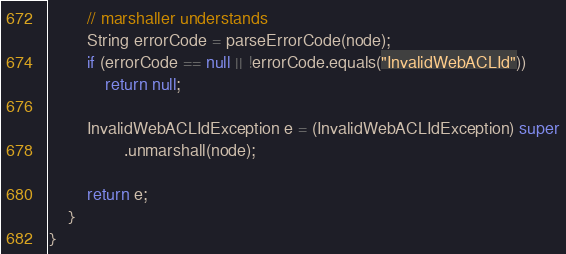<code> <loc_0><loc_0><loc_500><loc_500><_Java_>        // marshaller understands
        String errorCode = parseErrorCode(node);
        if (errorCode == null || !errorCode.equals("InvalidWebACLId"))
            return null;

        InvalidWebACLIdException e = (InvalidWebACLIdException) super
                .unmarshall(node);

        return e;
    }
}
</code> 